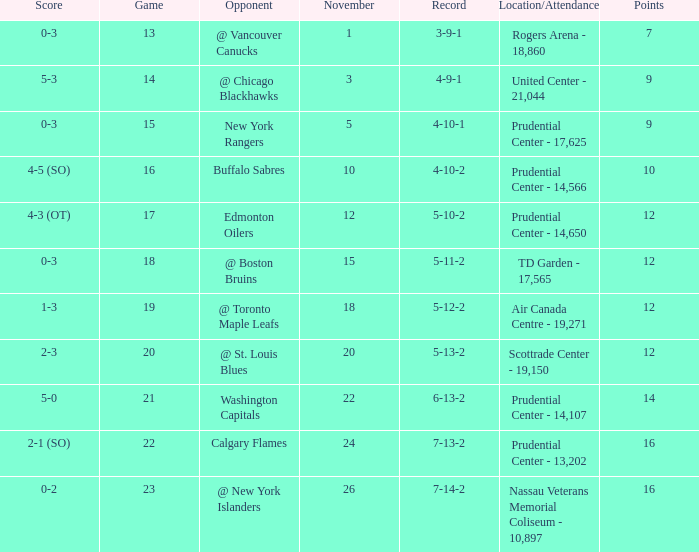What is the record for score 1-3? 5-12-2. 